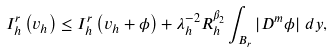<formula> <loc_0><loc_0><loc_500><loc_500>I _ { h } ^ { r } \left ( v _ { h } \right ) \leq I _ { h } ^ { r } \left ( v _ { h } + \phi \right ) + \lambda _ { h } ^ { - 2 } R _ { h } ^ { \beta _ { 2 } } \int _ { B _ { r } } \left | D ^ { m } \phi \right | \, d y ,</formula> 